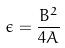<formula> <loc_0><loc_0><loc_500><loc_500>\epsilon = \frac { B ^ { 2 } } { 4 A }</formula> 